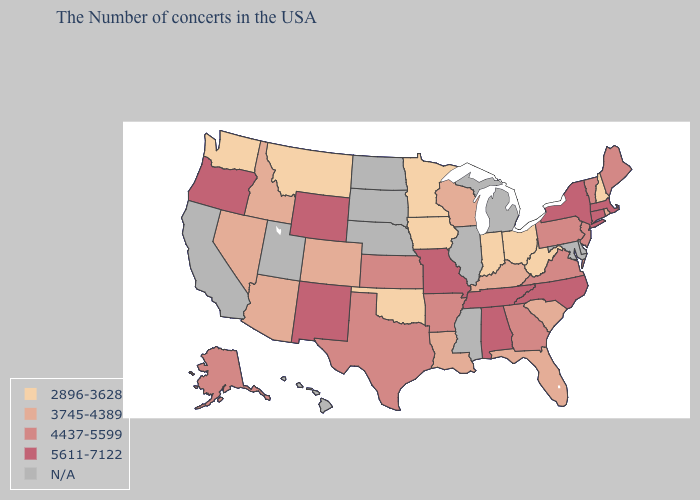Which states have the lowest value in the USA?
Give a very brief answer. New Hampshire, West Virginia, Ohio, Indiana, Minnesota, Iowa, Oklahoma, Montana, Washington. Name the states that have a value in the range 5611-7122?
Give a very brief answer. Massachusetts, Connecticut, New York, North Carolina, Alabama, Tennessee, Missouri, Wyoming, New Mexico, Oregon. Which states hav the highest value in the MidWest?
Quick response, please. Missouri. Which states have the lowest value in the MidWest?
Quick response, please. Ohio, Indiana, Minnesota, Iowa. What is the lowest value in the USA?
Write a very short answer. 2896-3628. What is the value of Connecticut?
Answer briefly. 5611-7122. What is the value of Utah?
Write a very short answer. N/A. Among the states that border Pennsylvania , does New Jersey have the highest value?
Keep it brief. No. What is the value of Tennessee?
Keep it brief. 5611-7122. Name the states that have a value in the range 5611-7122?
Quick response, please. Massachusetts, Connecticut, New York, North Carolina, Alabama, Tennessee, Missouri, Wyoming, New Mexico, Oregon. Does the map have missing data?
Short answer required. Yes. What is the highest value in the MidWest ?
Be succinct. 5611-7122. Which states have the lowest value in the West?
Be succinct. Montana, Washington. Does Kansas have the lowest value in the USA?
Short answer required. No. Name the states that have a value in the range 5611-7122?
Short answer required. Massachusetts, Connecticut, New York, North Carolina, Alabama, Tennessee, Missouri, Wyoming, New Mexico, Oregon. 